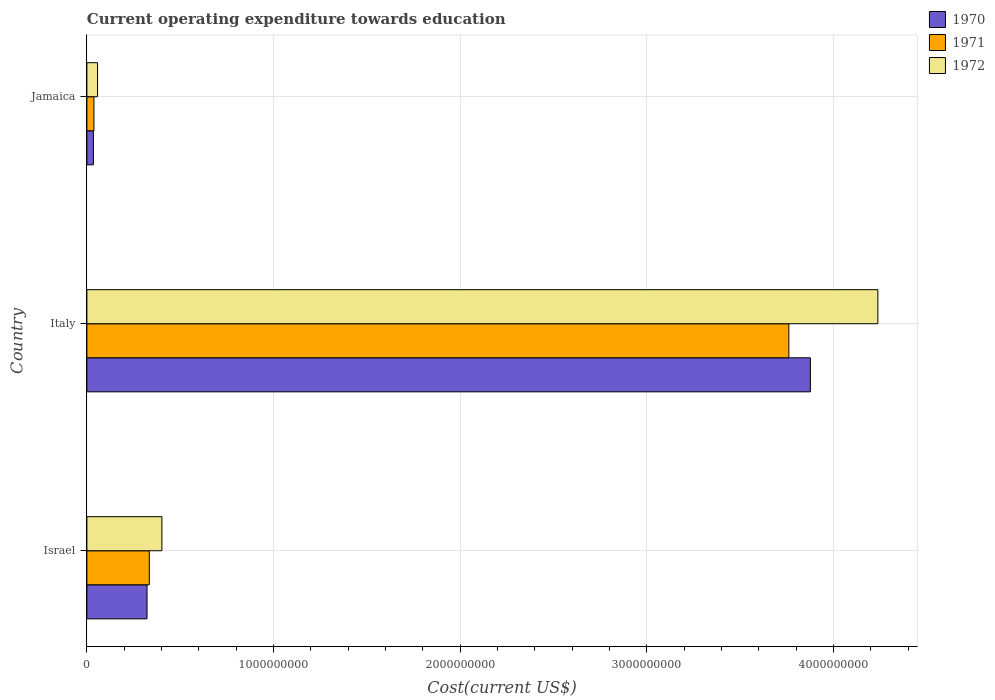How many groups of bars are there?
Make the answer very short. 3. Are the number of bars per tick equal to the number of legend labels?
Give a very brief answer. Yes. Are the number of bars on each tick of the Y-axis equal?
Your answer should be compact. Yes. How many bars are there on the 1st tick from the top?
Your answer should be compact. 3. How many bars are there on the 1st tick from the bottom?
Offer a terse response. 3. In how many cases, is the number of bars for a given country not equal to the number of legend labels?
Your answer should be compact. 0. What is the expenditure towards education in 1971 in Italy?
Your answer should be compact. 3.76e+09. Across all countries, what is the maximum expenditure towards education in 1971?
Provide a succinct answer. 3.76e+09. Across all countries, what is the minimum expenditure towards education in 1971?
Provide a succinct answer. 3.77e+07. In which country was the expenditure towards education in 1971 maximum?
Offer a very short reply. Italy. In which country was the expenditure towards education in 1972 minimum?
Your response must be concise. Jamaica. What is the total expenditure towards education in 1970 in the graph?
Your response must be concise. 4.23e+09. What is the difference between the expenditure towards education in 1971 in Italy and that in Jamaica?
Your response must be concise. 3.72e+09. What is the difference between the expenditure towards education in 1970 in Israel and the expenditure towards education in 1972 in Italy?
Make the answer very short. -3.92e+09. What is the average expenditure towards education in 1971 per country?
Your answer should be very brief. 1.38e+09. What is the difference between the expenditure towards education in 1972 and expenditure towards education in 1970 in Jamaica?
Offer a very short reply. 2.22e+07. In how many countries, is the expenditure towards education in 1972 greater than 3800000000 US$?
Offer a very short reply. 1. What is the ratio of the expenditure towards education in 1972 in Israel to that in Italy?
Offer a very short reply. 0.09. Is the difference between the expenditure towards education in 1972 in Italy and Jamaica greater than the difference between the expenditure towards education in 1970 in Italy and Jamaica?
Offer a terse response. Yes. What is the difference between the highest and the second highest expenditure towards education in 1972?
Provide a short and direct response. 3.84e+09. What is the difference between the highest and the lowest expenditure towards education in 1971?
Keep it short and to the point. 3.72e+09. What does the 3rd bar from the bottom in Israel represents?
Provide a succinct answer. 1972. Is it the case that in every country, the sum of the expenditure towards education in 1971 and expenditure towards education in 1972 is greater than the expenditure towards education in 1970?
Your response must be concise. Yes. How many bars are there?
Your answer should be compact. 9. Are all the bars in the graph horizontal?
Make the answer very short. Yes. How many countries are there in the graph?
Make the answer very short. 3. Does the graph contain any zero values?
Offer a very short reply. No. Where does the legend appear in the graph?
Provide a short and direct response. Top right. What is the title of the graph?
Provide a succinct answer. Current operating expenditure towards education. Does "1980" appear as one of the legend labels in the graph?
Offer a very short reply. No. What is the label or title of the X-axis?
Give a very brief answer. Cost(current US$). What is the Cost(current US$) of 1970 in Israel?
Provide a short and direct response. 3.22e+08. What is the Cost(current US$) in 1971 in Israel?
Your response must be concise. 3.34e+08. What is the Cost(current US$) in 1972 in Israel?
Keep it short and to the point. 4.02e+08. What is the Cost(current US$) in 1970 in Italy?
Offer a terse response. 3.88e+09. What is the Cost(current US$) of 1971 in Italy?
Keep it short and to the point. 3.76e+09. What is the Cost(current US$) in 1972 in Italy?
Provide a succinct answer. 4.24e+09. What is the Cost(current US$) of 1970 in Jamaica?
Keep it short and to the point. 3.49e+07. What is the Cost(current US$) of 1971 in Jamaica?
Your answer should be compact. 3.77e+07. What is the Cost(current US$) in 1972 in Jamaica?
Your response must be concise. 5.71e+07. Across all countries, what is the maximum Cost(current US$) of 1970?
Your answer should be compact. 3.88e+09. Across all countries, what is the maximum Cost(current US$) in 1971?
Make the answer very short. 3.76e+09. Across all countries, what is the maximum Cost(current US$) of 1972?
Keep it short and to the point. 4.24e+09. Across all countries, what is the minimum Cost(current US$) in 1970?
Your response must be concise. 3.49e+07. Across all countries, what is the minimum Cost(current US$) in 1971?
Provide a succinct answer. 3.77e+07. Across all countries, what is the minimum Cost(current US$) in 1972?
Make the answer very short. 5.71e+07. What is the total Cost(current US$) in 1970 in the graph?
Offer a terse response. 4.23e+09. What is the total Cost(current US$) of 1971 in the graph?
Keep it short and to the point. 4.13e+09. What is the total Cost(current US$) in 1972 in the graph?
Give a very brief answer. 4.70e+09. What is the difference between the Cost(current US$) in 1970 in Israel and that in Italy?
Keep it short and to the point. -3.55e+09. What is the difference between the Cost(current US$) in 1971 in Israel and that in Italy?
Keep it short and to the point. -3.43e+09. What is the difference between the Cost(current US$) of 1972 in Israel and that in Italy?
Your answer should be compact. -3.84e+09. What is the difference between the Cost(current US$) in 1970 in Israel and that in Jamaica?
Your answer should be very brief. 2.87e+08. What is the difference between the Cost(current US$) of 1971 in Israel and that in Jamaica?
Provide a succinct answer. 2.97e+08. What is the difference between the Cost(current US$) of 1972 in Israel and that in Jamaica?
Offer a terse response. 3.45e+08. What is the difference between the Cost(current US$) of 1970 in Italy and that in Jamaica?
Provide a succinct answer. 3.84e+09. What is the difference between the Cost(current US$) of 1971 in Italy and that in Jamaica?
Keep it short and to the point. 3.72e+09. What is the difference between the Cost(current US$) in 1972 in Italy and that in Jamaica?
Your answer should be very brief. 4.18e+09. What is the difference between the Cost(current US$) of 1970 in Israel and the Cost(current US$) of 1971 in Italy?
Keep it short and to the point. -3.44e+09. What is the difference between the Cost(current US$) in 1970 in Israel and the Cost(current US$) in 1972 in Italy?
Your answer should be compact. -3.92e+09. What is the difference between the Cost(current US$) of 1971 in Israel and the Cost(current US$) of 1972 in Italy?
Give a very brief answer. -3.90e+09. What is the difference between the Cost(current US$) in 1970 in Israel and the Cost(current US$) in 1971 in Jamaica?
Your response must be concise. 2.85e+08. What is the difference between the Cost(current US$) in 1970 in Israel and the Cost(current US$) in 1972 in Jamaica?
Provide a succinct answer. 2.65e+08. What is the difference between the Cost(current US$) in 1971 in Israel and the Cost(current US$) in 1972 in Jamaica?
Offer a terse response. 2.77e+08. What is the difference between the Cost(current US$) in 1970 in Italy and the Cost(current US$) in 1971 in Jamaica?
Ensure brevity in your answer.  3.84e+09. What is the difference between the Cost(current US$) in 1970 in Italy and the Cost(current US$) in 1972 in Jamaica?
Provide a short and direct response. 3.82e+09. What is the difference between the Cost(current US$) of 1971 in Italy and the Cost(current US$) of 1972 in Jamaica?
Your answer should be compact. 3.70e+09. What is the average Cost(current US$) of 1970 per country?
Your answer should be compact. 1.41e+09. What is the average Cost(current US$) of 1971 per country?
Your answer should be compact. 1.38e+09. What is the average Cost(current US$) of 1972 per country?
Your response must be concise. 1.57e+09. What is the difference between the Cost(current US$) of 1970 and Cost(current US$) of 1971 in Israel?
Give a very brief answer. -1.22e+07. What is the difference between the Cost(current US$) in 1970 and Cost(current US$) in 1972 in Israel?
Provide a short and direct response. -7.96e+07. What is the difference between the Cost(current US$) of 1971 and Cost(current US$) of 1972 in Israel?
Provide a succinct answer. -6.74e+07. What is the difference between the Cost(current US$) in 1970 and Cost(current US$) in 1971 in Italy?
Provide a short and direct response. 1.15e+08. What is the difference between the Cost(current US$) of 1970 and Cost(current US$) of 1972 in Italy?
Give a very brief answer. -3.62e+08. What is the difference between the Cost(current US$) in 1971 and Cost(current US$) in 1972 in Italy?
Your answer should be very brief. -4.77e+08. What is the difference between the Cost(current US$) in 1970 and Cost(current US$) in 1971 in Jamaica?
Make the answer very short. -2.78e+06. What is the difference between the Cost(current US$) in 1970 and Cost(current US$) in 1972 in Jamaica?
Your response must be concise. -2.22e+07. What is the difference between the Cost(current US$) in 1971 and Cost(current US$) in 1972 in Jamaica?
Give a very brief answer. -1.94e+07. What is the ratio of the Cost(current US$) in 1970 in Israel to that in Italy?
Ensure brevity in your answer.  0.08. What is the ratio of the Cost(current US$) in 1971 in Israel to that in Italy?
Offer a very short reply. 0.09. What is the ratio of the Cost(current US$) of 1972 in Israel to that in Italy?
Provide a short and direct response. 0.09. What is the ratio of the Cost(current US$) in 1970 in Israel to that in Jamaica?
Your answer should be very brief. 9.22. What is the ratio of the Cost(current US$) of 1971 in Israel to that in Jamaica?
Provide a short and direct response. 8.87. What is the ratio of the Cost(current US$) in 1972 in Israel to that in Jamaica?
Your answer should be very brief. 7.04. What is the ratio of the Cost(current US$) of 1970 in Italy to that in Jamaica?
Your answer should be compact. 110.97. What is the ratio of the Cost(current US$) in 1971 in Italy to that in Jamaica?
Offer a very short reply. 99.73. What is the ratio of the Cost(current US$) of 1972 in Italy to that in Jamaica?
Give a very brief answer. 74.21. What is the difference between the highest and the second highest Cost(current US$) of 1970?
Your answer should be compact. 3.55e+09. What is the difference between the highest and the second highest Cost(current US$) of 1971?
Provide a short and direct response. 3.43e+09. What is the difference between the highest and the second highest Cost(current US$) in 1972?
Your answer should be very brief. 3.84e+09. What is the difference between the highest and the lowest Cost(current US$) of 1970?
Ensure brevity in your answer.  3.84e+09. What is the difference between the highest and the lowest Cost(current US$) in 1971?
Your answer should be compact. 3.72e+09. What is the difference between the highest and the lowest Cost(current US$) of 1972?
Your response must be concise. 4.18e+09. 